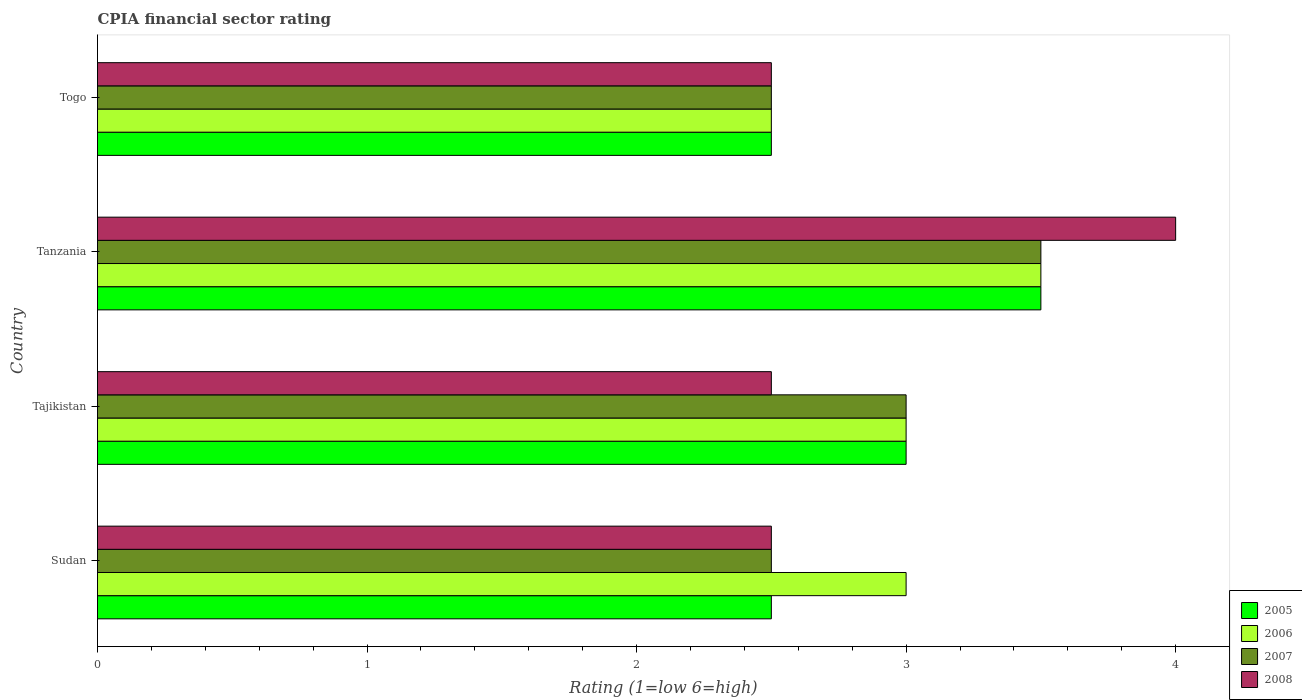How many different coloured bars are there?
Your response must be concise. 4. Are the number of bars per tick equal to the number of legend labels?
Offer a terse response. Yes. Are the number of bars on each tick of the Y-axis equal?
Ensure brevity in your answer.  Yes. How many bars are there on the 3rd tick from the top?
Your answer should be compact. 4. What is the label of the 3rd group of bars from the top?
Your answer should be very brief. Tajikistan. In how many cases, is the number of bars for a given country not equal to the number of legend labels?
Your response must be concise. 0. What is the CPIA rating in 2007 in Tajikistan?
Keep it short and to the point. 3. Across all countries, what is the minimum CPIA rating in 2005?
Your answer should be very brief. 2.5. In which country was the CPIA rating in 2008 maximum?
Keep it short and to the point. Tanzania. In which country was the CPIA rating in 2006 minimum?
Ensure brevity in your answer.  Togo. What is the total CPIA rating in 2008 in the graph?
Provide a short and direct response. 11.5. What is the average CPIA rating in 2008 per country?
Ensure brevity in your answer.  2.88. In how many countries, is the CPIA rating in 2005 greater than 2.6 ?
Offer a terse response. 2. What is the ratio of the CPIA rating in 2007 in Tajikistan to that in Tanzania?
Your answer should be very brief. 0.86. Is the CPIA rating in 2007 in Tanzania less than that in Togo?
Offer a terse response. No. What does the 3rd bar from the top in Togo represents?
Offer a terse response. 2006. What does the 4th bar from the bottom in Sudan represents?
Offer a terse response. 2008. Are all the bars in the graph horizontal?
Offer a very short reply. Yes. How many countries are there in the graph?
Give a very brief answer. 4. What is the difference between two consecutive major ticks on the X-axis?
Your answer should be very brief. 1. Are the values on the major ticks of X-axis written in scientific E-notation?
Your answer should be very brief. No. Where does the legend appear in the graph?
Your answer should be compact. Bottom right. How many legend labels are there?
Make the answer very short. 4. How are the legend labels stacked?
Your answer should be very brief. Vertical. What is the title of the graph?
Keep it short and to the point. CPIA financial sector rating. What is the Rating (1=low 6=high) in 2005 in Sudan?
Ensure brevity in your answer.  2.5. What is the Rating (1=low 6=high) of 2008 in Sudan?
Ensure brevity in your answer.  2.5. What is the Rating (1=low 6=high) in 2007 in Tajikistan?
Your answer should be compact. 3. What is the Rating (1=low 6=high) of 2007 in Tanzania?
Offer a terse response. 3.5. What is the Rating (1=low 6=high) of 2006 in Togo?
Ensure brevity in your answer.  2.5. What is the Rating (1=low 6=high) in 2008 in Togo?
Offer a very short reply. 2.5. Across all countries, what is the maximum Rating (1=low 6=high) of 2007?
Provide a succinct answer. 3.5. Across all countries, what is the maximum Rating (1=low 6=high) of 2008?
Your answer should be compact. 4. Across all countries, what is the minimum Rating (1=low 6=high) in 2008?
Provide a succinct answer. 2.5. What is the total Rating (1=low 6=high) of 2007 in the graph?
Provide a short and direct response. 11.5. What is the total Rating (1=low 6=high) of 2008 in the graph?
Make the answer very short. 11.5. What is the difference between the Rating (1=low 6=high) of 2007 in Sudan and that in Tajikistan?
Provide a succinct answer. -0.5. What is the difference between the Rating (1=low 6=high) in 2008 in Sudan and that in Tajikistan?
Keep it short and to the point. 0. What is the difference between the Rating (1=low 6=high) of 2005 in Sudan and that in Tanzania?
Give a very brief answer. -1. What is the difference between the Rating (1=low 6=high) in 2005 in Tajikistan and that in Tanzania?
Ensure brevity in your answer.  -0.5. What is the difference between the Rating (1=low 6=high) of 2007 in Tajikistan and that in Tanzania?
Provide a short and direct response. -0.5. What is the difference between the Rating (1=low 6=high) in 2006 in Tajikistan and that in Togo?
Ensure brevity in your answer.  0.5. What is the difference between the Rating (1=low 6=high) of 2007 in Tajikistan and that in Togo?
Provide a short and direct response. 0.5. What is the difference between the Rating (1=low 6=high) in 2008 in Tajikistan and that in Togo?
Offer a very short reply. 0. What is the difference between the Rating (1=low 6=high) of 2006 in Tanzania and that in Togo?
Offer a very short reply. 1. What is the difference between the Rating (1=low 6=high) of 2005 in Sudan and the Rating (1=low 6=high) of 2008 in Tajikistan?
Offer a terse response. 0. What is the difference between the Rating (1=low 6=high) in 2006 in Sudan and the Rating (1=low 6=high) in 2007 in Tajikistan?
Keep it short and to the point. 0. What is the difference between the Rating (1=low 6=high) in 2006 in Sudan and the Rating (1=low 6=high) in 2008 in Tajikistan?
Give a very brief answer. 0.5. What is the difference between the Rating (1=low 6=high) of 2007 in Sudan and the Rating (1=low 6=high) of 2008 in Tajikistan?
Give a very brief answer. 0. What is the difference between the Rating (1=low 6=high) in 2005 in Sudan and the Rating (1=low 6=high) in 2007 in Tanzania?
Make the answer very short. -1. What is the difference between the Rating (1=low 6=high) of 2006 in Sudan and the Rating (1=low 6=high) of 2007 in Tanzania?
Your answer should be compact. -0.5. What is the difference between the Rating (1=low 6=high) of 2006 in Sudan and the Rating (1=low 6=high) of 2008 in Tanzania?
Provide a short and direct response. -1. What is the difference between the Rating (1=low 6=high) of 2007 in Sudan and the Rating (1=low 6=high) of 2008 in Tanzania?
Keep it short and to the point. -1.5. What is the difference between the Rating (1=low 6=high) of 2005 in Sudan and the Rating (1=low 6=high) of 2007 in Togo?
Offer a very short reply. 0. What is the difference between the Rating (1=low 6=high) of 2006 in Sudan and the Rating (1=low 6=high) of 2007 in Togo?
Your answer should be very brief. 0.5. What is the difference between the Rating (1=low 6=high) of 2007 in Sudan and the Rating (1=low 6=high) of 2008 in Togo?
Make the answer very short. 0. What is the difference between the Rating (1=low 6=high) of 2005 in Tajikistan and the Rating (1=low 6=high) of 2006 in Tanzania?
Provide a short and direct response. -0.5. What is the difference between the Rating (1=low 6=high) of 2005 in Tajikistan and the Rating (1=low 6=high) of 2008 in Tanzania?
Ensure brevity in your answer.  -1. What is the difference between the Rating (1=low 6=high) in 2006 in Tajikistan and the Rating (1=low 6=high) in 2007 in Tanzania?
Your response must be concise. -0.5. What is the difference between the Rating (1=low 6=high) of 2005 in Tajikistan and the Rating (1=low 6=high) of 2006 in Togo?
Give a very brief answer. 0.5. What is the difference between the Rating (1=low 6=high) of 2005 in Tajikistan and the Rating (1=low 6=high) of 2007 in Togo?
Make the answer very short. 0.5. What is the difference between the Rating (1=low 6=high) in 2005 in Tajikistan and the Rating (1=low 6=high) in 2008 in Togo?
Keep it short and to the point. 0.5. What is the difference between the Rating (1=low 6=high) of 2006 in Tajikistan and the Rating (1=low 6=high) of 2007 in Togo?
Provide a short and direct response. 0.5. What is the difference between the Rating (1=low 6=high) of 2005 in Tanzania and the Rating (1=low 6=high) of 2006 in Togo?
Ensure brevity in your answer.  1. What is the difference between the Rating (1=low 6=high) of 2006 in Tanzania and the Rating (1=low 6=high) of 2008 in Togo?
Provide a succinct answer. 1. What is the difference between the Rating (1=low 6=high) in 2007 in Tanzania and the Rating (1=low 6=high) in 2008 in Togo?
Provide a succinct answer. 1. What is the average Rating (1=low 6=high) of 2005 per country?
Your answer should be compact. 2.88. What is the average Rating (1=low 6=high) of 2006 per country?
Keep it short and to the point. 3. What is the average Rating (1=low 6=high) in 2007 per country?
Ensure brevity in your answer.  2.88. What is the average Rating (1=low 6=high) of 2008 per country?
Your response must be concise. 2.88. What is the difference between the Rating (1=low 6=high) in 2006 and Rating (1=low 6=high) in 2008 in Sudan?
Offer a very short reply. 0.5. What is the difference between the Rating (1=low 6=high) of 2007 and Rating (1=low 6=high) of 2008 in Tajikistan?
Provide a succinct answer. 0.5. What is the difference between the Rating (1=low 6=high) in 2005 and Rating (1=low 6=high) in 2007 in Tanzania?
Ensure brevity in your answer.  0. What is the difference between the Rating (1=low 6=high) in 2006 and Rating (1=low 6=high) in 2007 in Tanzania?
Offer a very short reply. 0. What is the difference between the Rating (1=low 6=high) in 2006 and Rating (1=low 6=high) in 2007 in Togo?
Give a very brief answer. 0. What is the ratio of the Rating (1=low 6=high) of 2005 in Sudan to that in Tajikistan?
Your answer should be very brief. 0.83. What is the ratio of the Rating (1=low 6=high) of 2006 in Sudan to that in Tajikistan?
Your response must be concise. 1. What is the ratio of the Rating (1=low 6=high) in 2007 in Sudan to that in Tajikistan?
Provide a succinct answer. 0.83. What is the ratio of the Rating (1=low 6=high) of 2006 in Sudan to that in Tanzania?
Ensure brevity in your answer.  0.86. What is the ratio of the Rating (1=low 6=high) in 2005 in Sudan to that in Togo?
Your answer should be very brief. 1. What is the ratio of the Rating (1=low 6=high) of 2006 in Sudan to that in Togo?
Ensure brevity in your answer.  1.2. What is the ratio of the Rating (1=low 6=high) of 2008 in Sudan to that in Togo?
Keep it short and to the point. 1. What is the ratio of the Rating (1=low 6=high) of 2007 in Tajikistan to that in Tanzania?
Ensure brevity in your answer.  0.86. What is the ratio of the Rating (1=low 6=high) of 2006 in Tajikistan to that in Togo?
Offer a very short reply. 1.2. What is the ratio of the Rating (1=low 6=high) of 2007 in Tajikistan to that in Togo?
Your answer should be compact. 1.2. What is the ratio of the Rating (1=low 6=high) of 2008 in Tajikistan to that in Togo?
Your response must be concise. 1. What is the ratio of the Rating (1=low 6=high) of 2005 in Tanzania to that in Togo?
Your response must be concise. 1.4. What is the ratio of the Rating (1=low 6=high) of 2006 in Tanzania to that in Togo?
Offer a terse response. 1.4. What is the ratio of the Rating (1=low 6=high) in 2007 in Tanzania to that in Togo?
Your answer should be compact. 1.4. What is the difference between the highest and the second highest Rating (1=low 6=high) of 2005?
Your answer should be compact. 0.5. What is the difference between the highest and the second highest Rating (1=low 6=high) of 2006?
Give a very brief answer. 0.5. What is the difference between the highest and the second highest Rating (1=low 6=high) in 2007?
Offer a terse response. 0.5. What is the difference between the highest and the lowest Rating (1=low 6=high) of 2005?
Offer a very short reply. 1. What is the difference between the highest and the lowest Rating (1=low 6=high) in 2008?
Make the answer very short. 1.5. 